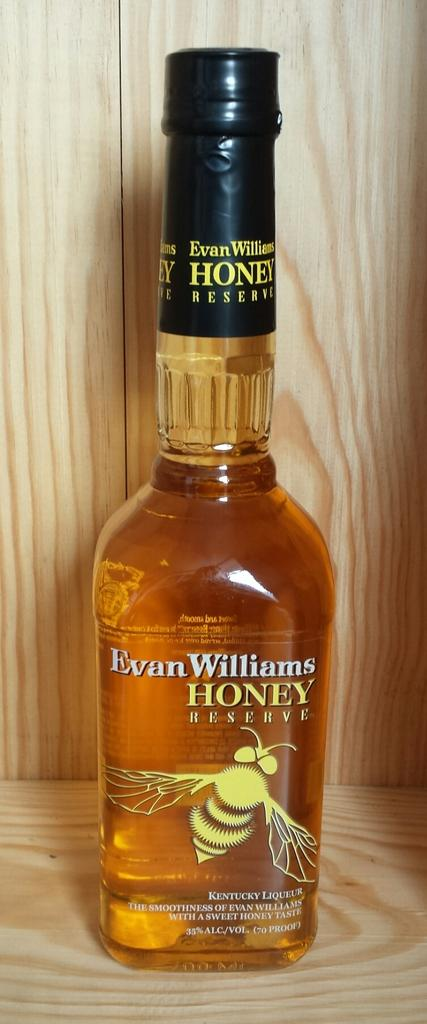<image>
Present a compact description of the photo's key features. A large bottle of Evan Williams Honey with a bee on the bottle. 